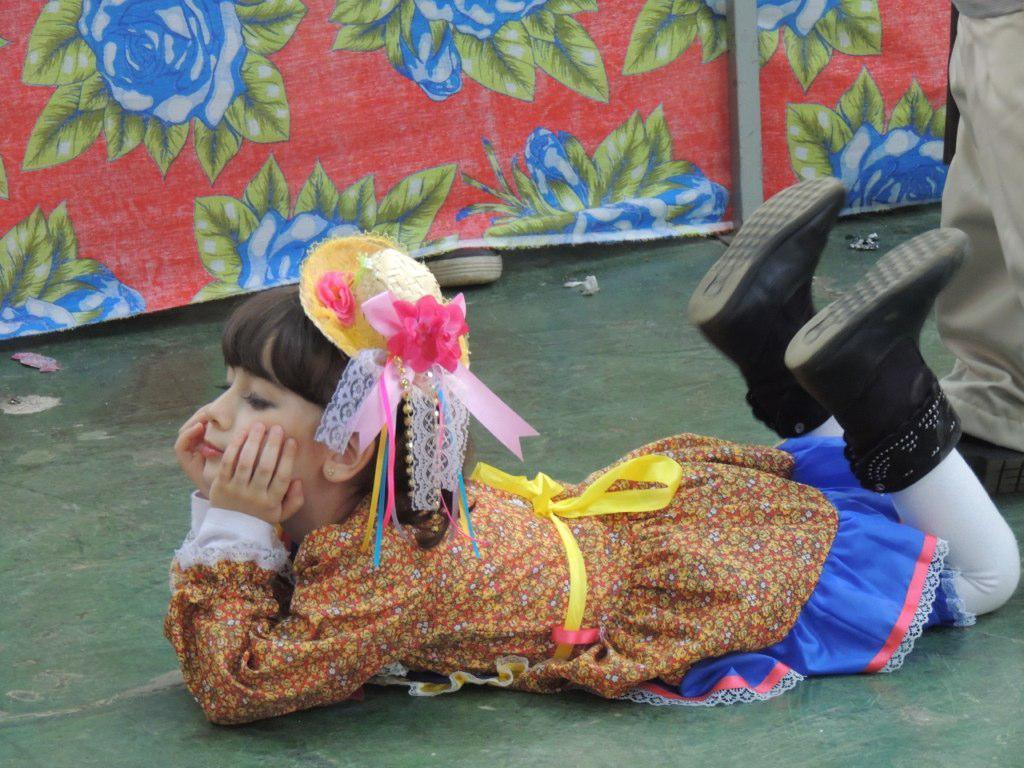What is the girl doing in the image? The girl is laying on the floor in the image. How many people are present in the image? There is one person, the girl, in the image. What can be seen in the background of the image? There is a cloth and an iron rod in the background of the image. What type of substance can be seen being sold at the market in the image? There is no market or substance being sold present in the image. 